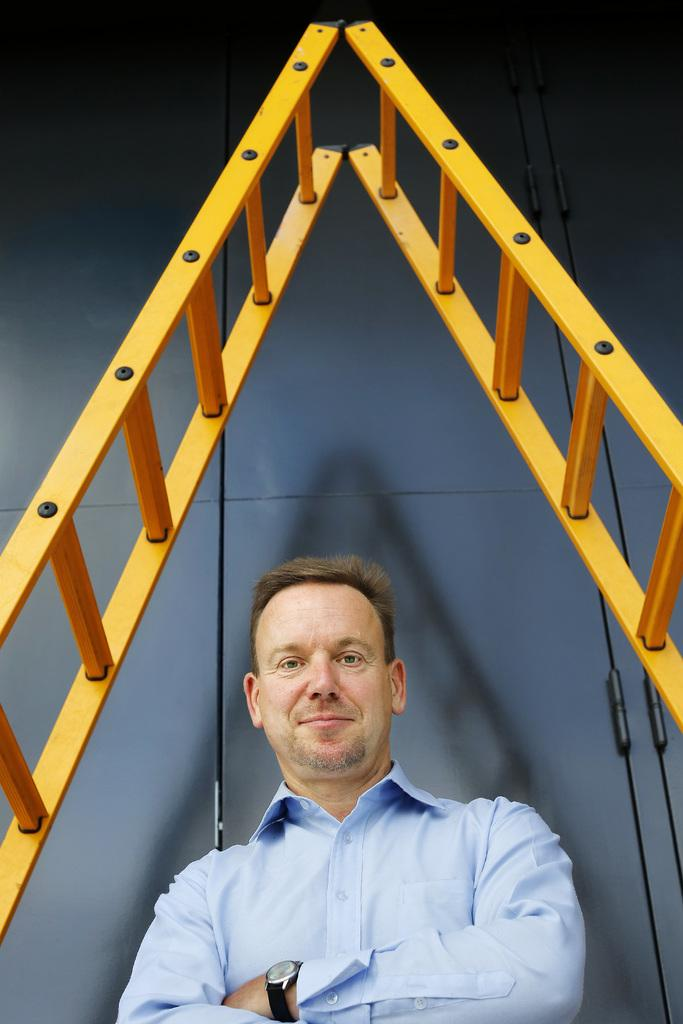What is the man in the image doing? The man is standing in the image. What expression does the man have on his face? The man is smiling. What color is the shirt the man is wearing? The man is wearing a blue shirt. What accessory is the man wearing on his wrist? The man is wearing a watch. What objects can be seen in the image that are used for reaching higher places? There are ladders visible in the image. What type of fish can be seen swimming in the image? There are no fish present in the image; it features a man standing and smiling, wearing a blue shirt and a watch, with ladders visible in the background. 